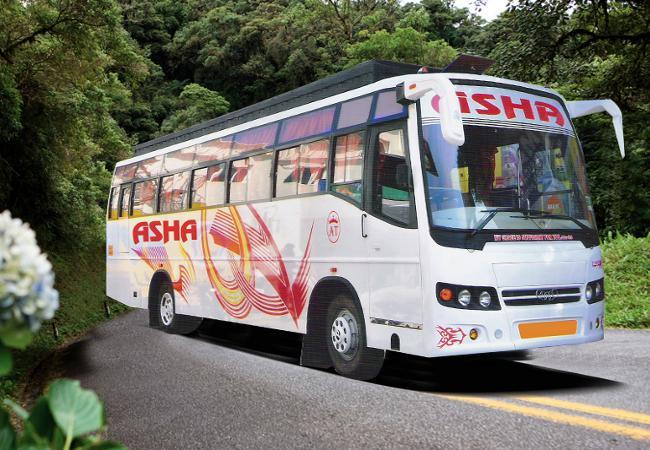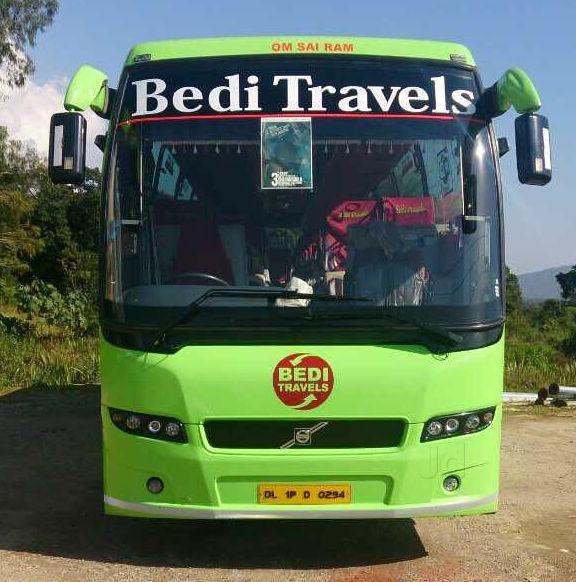The first image is the image on the left, the second image is the image on the right. For the images shown, is this caption "The left image shows one primarily white bus with a flat, slightly sloped front displayed at an angle facing rightward." true? Answer yes or no. Yes. The first image is the image on the left, the second image is the image on the right. Evaluate the accuracy of this statement regarding the images: "The left and right image contains the same number of travel buses.". Is it true? Answer yes or no. Yes. 